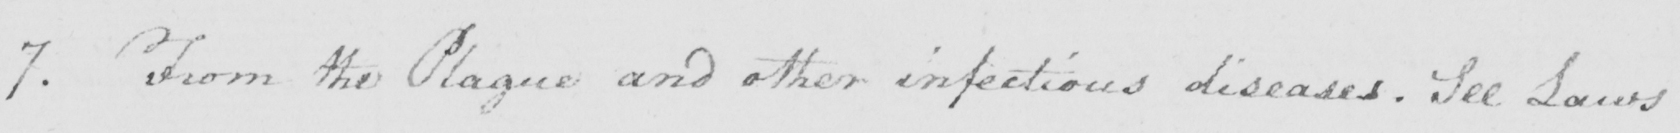What does this handwritten line say? 7 . From the Plague and other infectious diseases . See Laws 